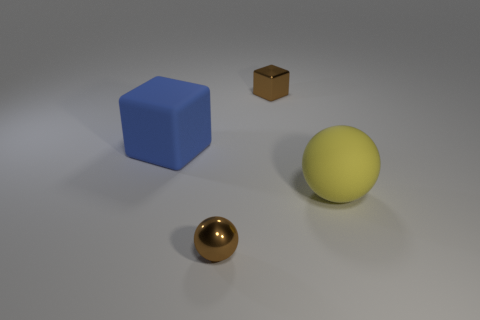Add 4 blue rubber blocks. How many objects exist? 8 Subtract all yellow balls. How many balls are left? 1 Subtract 2 spheres. How many spheres are left? 0 Subtract 0 purple spheres. How many objects are left? 4 Subtract all blue cubes. Subtract all purple cylinders. How many cubes are left? 1 Subtract all yellow cylinders. How many brown blocks are left? 1 Subtract all brown rubber blocks. Subtract all rubber blocks. How many objects are left? 3 Add 2 tiny brown metal spheres. How many tiny brown metal spheres are left? 3 Add 1 yellow rubber things. How many yellow rubber things exist? 2 